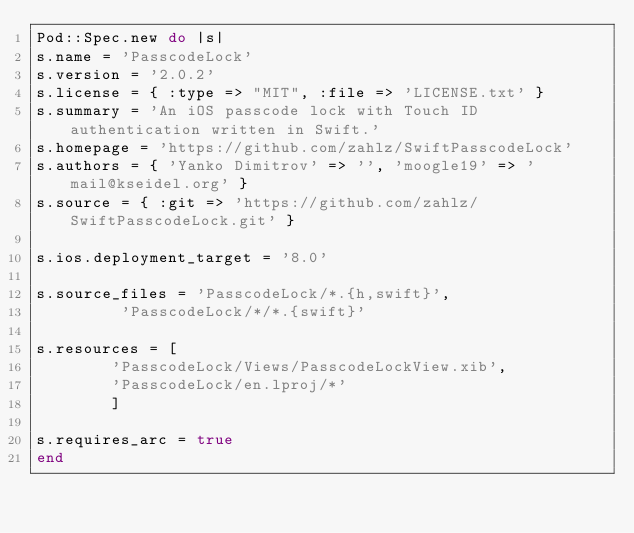<code> <loc_0><loc_0><loc_500><loc_500><_Ruby_>Pod::Spec.new do |s|
s.name = 'PasscodeLock'
s.version = '2.0.2'
s.license = { :type => "MIT", :file => 'LICENSE.txt' }
s.summary = 'An iOS passcode lock with Touch ID authentication written in Swift.'
s.homepage = 'https://github.com/zahlz/SwiftPasscodeLock'
s.authors = { 'Yanko Dimitrov' => '', 'moogle19' => 'mail@kseidel.org' }
s.source = { :git => 'https://github.com/zahlz/SwiftPasscodeLock.git' }

s.ios.deployment_target = '8.0'

s.source_files = 'PasscodeLock/*.{h,swift}',
				 'PasscodeLock/*/*.{swift}'

s.resources = [
				'PasscodeLock/Views/PasscodeLockView.xib',
				'PasscodeLock/en.lproj/*'
			  ]

s.requires_arc = true
end
</code> 